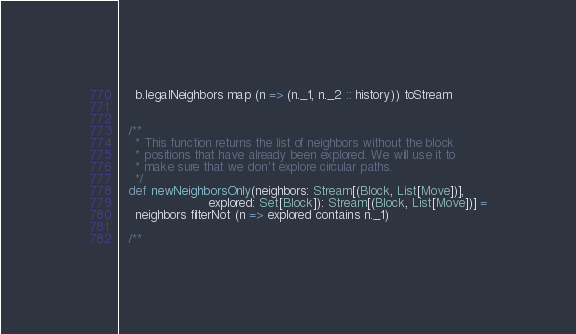<code> <loc_0><loc_0><loc_500><loc_500><_Scala_>    b.legalNeighbors map (n => (n._1, n._2 :: history)) toStream


  /**
    * This function returns the list of neighbors without the block
    * positions that have already been explored. We will use it to
    * make sure that we don't explore circular paths.
    */
  def newNeighborsOnly(neighbors: Stream[(Block, List[Move])],
                       explored: Set[Block]): Stream[(Block, List[Move])] =
    neighbors filterNot (n => explored contains n._1)

  /**</code> 